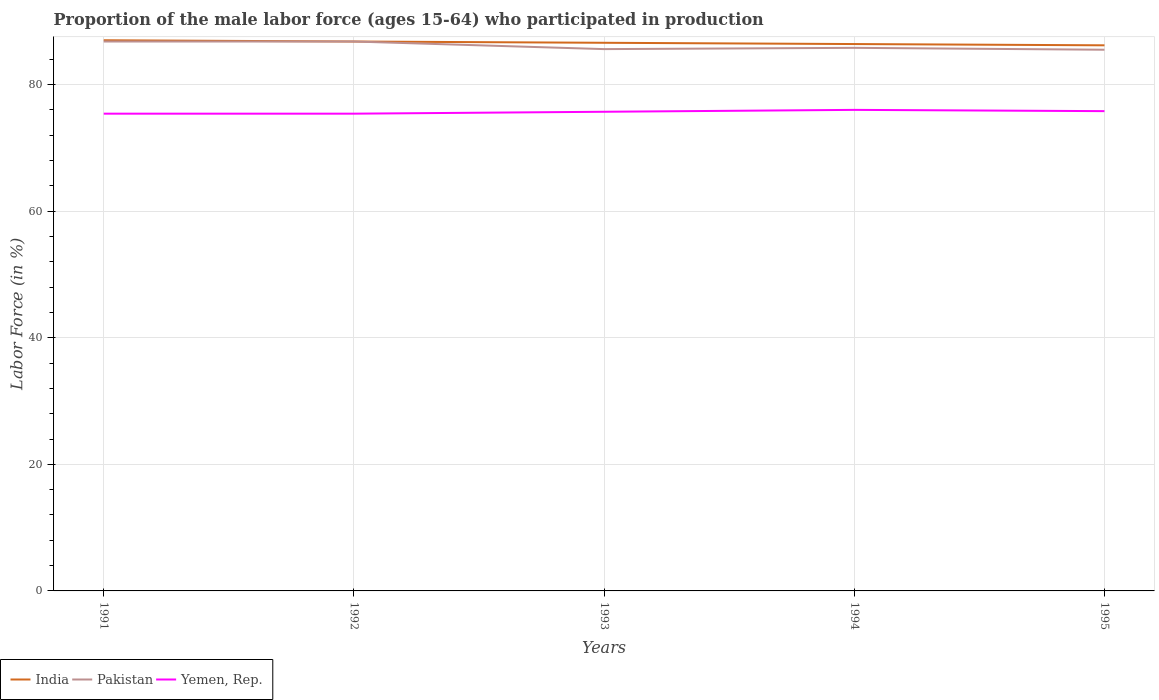Does the line corresponding to Pakistan intersect with the line corresponding to Yemen, Rep.?
Provide a succinct answer. No. Is the number of lines equal to the number of legend labels?
Your response must be concise. Yes. Across all years, what is the maximum proportion of the male labor force who participated in production in Yemen, Rep.?
Your response must be concise. 75.4. What is the total proportion of the male labor force who participated in production in India in the graph?
Your answer should be very brief. 0.4. What is the difference between the highest and the second highest proportion of the male labor force who participated in production in Pakistan?
Give a very brief answer. 1.3. Does the graph contain grids?
Make the answer very short. Yes. Where does the legend appear in the graph?
Your answer should be compact. Bottom left. How many legend labels are there?
Offer a terse response. 3. How are the legend labels stacked?
Provide a short and direct response. Horizontal. What is the title of the graph?
Give a very brief answer. Proportion of the male labor force (ages 15-64) who participated in production. What is the label or title of the X-axis?
Your answer should be very brief. Years. What is the Labor Force (in %) in Pakistan in 1991?
Give a very brief answer. 86.8. What is the Labor Force (in %) in Yemen, Rep. in 1991?
Make the answer very short. 75.4. What is the Labor Force (in %) in India in 1992?
Make the answer very short. 86.8. What is the Labor Force (in %) in Pakistan in 1992?
Provide a succinct answer. 86.8. What is the Labor Force (in %) of Yemen, Rep. in 1992?
Your response must be concise. 75.4. What is the Labor Force (in %) in India in 1993?
Your answer should be very brief. 86.6. What is the Labor Force (in %) in Pakistan in 1993?
Ensure brevity in your answer.  85.6. What is the Labor Force (in %) of Yemen, Rep. in 1993?
Offer a very short reply. 75.7. What is the Labor Force (in %) of India in 1994?
Make the answer very short. 86.4. What is the Labor Force (in %) of Pakistan in 1994?
Provide a short and direct response. 85.8. What is the Labor Force (in %) of Yemen, Rep. in 1994?
Ensure brevity in your answer.  76. What is the Labor Force (in %) of India in 1995?
Your answer should be very brief. 86.2. What is the Labor Force (in %) of Pakistan in 1995?
Ensure brevity in your answer.  85.5. What is the Labor Force (in %) in Yemen, Rep. in 1995?
Offer a very short reply. 75.8. Across all years, what is the maximum Labor Force (in %) of Pakistan?
Ensure brevity in your answer.  86.8. Across all years, what is the maximum Labor Force (in %) of Yemen, Rep.?
Ensure brevity in your answer.  76. Across all years, what is the minimum Labor Force (in %) of India?
Ensure brevity in your answer.  86.2. Across all years, what is the minimum Labor Force (in %) of Pakistan?
Keep it short and to the point. 85.5. Across all years, what is the minimum Labor Force (in %) in Yemen, Rep.?
Your answer should be very brief. 75.4. What is the total Labor Force (in %) of India in the graph?
Provide a succinct answer. 433. What is the total Labor Force (in %) of Pakistan in the graph?
Offer a terse response. 430.5. What is the total Labor Force (in %) in Yemen, Rep. in the graph?
Provide a succinct answer. 378.3. What is the difference between the Labor Force (in %) in Pakistan in 1991 and that in 1992?
Provide a short and direct response. 0. What is the difference between the Labor Force (in %) in Pakistan in 1991 and that in 1993?
Your response must be concise. 1.2. What is the difference between the Labor Force (in %) in Yemen, Rep. in 1991 and that in 1993?
Offer a very short reply. -0.3. What is the difference between the Labor Force (in %) of Pakistan in 1991 and that in 1994?
Your answer should be very brief. 1. What is the difference between the Labor Force (in %) in Yemen, Rep. in 1991 and that in 1994?
Your response must be concise. -0.6. What is the difference between the Labor Force (in %) in India in 1991 and that in 1995?
Offer a very short reply. 0.8. What is the difference between the Labor Force (in %) in Pakistan in 1991 and that in 1995?
Offer a terse response. 1.3. What is the difference between the Labor Force (in %) of Yemen, Rep. in 1991 and that in 1995?
Offer a terse response. -0.4. What is the difference between the Labor Force (in %) in India in 1992 and that in 1993?
Provide a succinct answer. 0.2. What is the difference between the Labor Force (in %) in India in 1992 and that in 1994?
Your response must be concise. 0.4. What is the difference between the Labor Force (in %) in Pakistan in 1992 and that in 1994?
Ensure brevity in your answer.  1. What is the difference between the Labor Force (in %) in Yemen, Rep. in 1992 and that in 1994?
Ensure brevity in your answer.  -0.6. What is the difference between the Labor Force (in %) in Yemen, Rep. in 1992 and that in 1995?
Provide a short and direct response. -0.4. What is the difference between the Labor Force (in %) of Pakistan in 1993 and that in 1994?
Provide a short and direct response. -0.2. What is the difference between the Labor Force (in %) in Yemen, Rep. in 1993 and that in 1994?
Provide a succinct answer. -0.3. What is the difference between the Labor Force (in %) of Pakistan in 1993 and that in 1995?
Your answer should be compact. 0.1. What is the difference between the Labor Force (in %) of India in 1994 and that in 1995?
Give a very brief answer. 0.2. What is the difference between the Labor Force (in %) in Pakistan in 1994 and that in 1995?
Offer a very short reply. 0.3. What is the difference between the Labor Force (in %) in Yemen, Rep. in 1994 and that in 1995?
Keep it short and to the point. 0.2. What is the difference between the Labor Force (in %) in India in 1991 and the Labor Force (in %) in Yemen, Rep. in 1992?
Offer a very short reply. 11.6. What is the difference between the Labor Force (in %) in India in 1991 and the Labor Force (in %) in Yemen, Rep. in 1993?
Offer a terse response. 11.3. What is the difference between the Labor Force (in %) of India in 1992 and the Labor Force (in %) of Yemen, Rep. in 1993?
Provide a short and direct response. 11.1. What is the difference between the Labor Force (in %) in India in 1992 and the Labor Force (in %) in Yemen, Rep. in 1994?
Keep it short and to the point. 10.8. What is the difference between the Labor Force (in %) of India in 1992 and the Labor Force (in %) of Pakistan in 1995?
Provide a short and direct response. 1.3. What is the difference between the Labor Force (in %) of Pakistan in 1992 and the Labor Force (in %) of Yemen, Rep. in 1995?
Provide a succinct answer. 11. What is the difference between the Labor Force (in %) in India in 1993 and the Labor Force (in %) in Pakistan in 1994?
Offer a terse response. 0.8. What is the difference between the Labor Force (in %) of India in 1993 and the Labor Force (in %) of Yemen, Rep. in 1994?
Provide a succinct answer. 10.6. What is the difference between the Labor Force (in %) of Pakistan in 1993 and the Labor Force (in %) of Yemen, Rep. in 1994?
Make the answer very short. 9.6. What is the difference between the Labor Force (in %) in India in 1994 and the Labor Force (in %) in Pakistan in 1995?
Provide a succinct answer. 0.9. What is the difference between the Labor Force (in %) of India in 1994 and the Labor Force (in %) of Yemen, Rep. in 1995?
Provide a short and direct response. 10.6. What is the average Labor Force (in %) in India per year?
Your response must be concise. 86.6. What is the average Labor Force (in %) in Pakistan per year?
Offer a very short reply. 86.1. What is the average Labor Force (in %) of Yemen, Rep. per year?
Offer a very short reply. 75.66. In the year 1991, what is the difference between the Labor Force (in %) in India and Labor Force (in %) in Yemen, Rep.?
Provide a short and direct response. 11.6. In the year 1991, what is the difference between the Labor Force (in %) of Pakistan and Labor Force (in %) of Yemen, Rep.?
Your answer should be very brief. 11.4. In the year 1992, what is the difference between the Labor Force (in %) in India and Labor Force (in %) in Pakistan?
Keep it short and to the point. 0. In the year 1992, what is the difference between the Labor Force (in %) of India and Labor Force (in %) of Yemen, Rep.?
Provide a short and direct response. 11.4. In the year 1992, what is the difference between the Labor Force (in %) of Pakistan and Labor Force (in %) of Yemen, Rep.?
Ensure brevity in your answer.  11.4. In the year 1993, what is the difference between the Labor Force (in %) of India and Labor Force (in %) of Pakistan?
Offer a terse response. 1. In the year 1993, what is the difference between the Labor Force (in %) of India and Labor Force (in %) of Yemen, Rep.?
Your response must be concise. 10.9. In the year 1993, what is the difference between the Labor Force (in %) of Pakistan and Labor Force (in %) of Yemen, Rep.?
Keep it short and to the point. 9.9. In the year 1994, what is the difference between the Labor Force (in %) in India and Labor Force (in %) in Yemen, Rep.?
Offer a very short reply. 10.4. In the year 1994, what is the difference between the Labor Force (in %) of Pakistan and Labor Force (in %) of Yemen, Rep.?
Give a very brief answer. 9.8. In the year 1995, what is the difference between the Labor Force (in %) of India and Labor Force (in %) of Pakistan?
Provide a short and direct response. 0.7. What is the ratio of the Labor Force (in %) in Pakistan in 1991 to that in 1992?
Your answer should be compact. 1. What is the ratio of the Labor Force (in %) of India in 1991 to that in 1993?
Give a very brief answer. 1. What is the ratio of the Labor Force (in %) in Pakistan in 1991 to that in 1993?
Make the answer very short. 1.01. What is the ratio of the Labor Force (in %) in Yemen, Rep. in 1991 to that in 1993?
Give a very brief answer. 1. What is the ratio of the Labor Force (in %) in India in 1991 to that in 1994?
Your answer should be compact. 1.01. What is the ratio of the Labor Force (in %) in Pakistan in 1991 to that in 1994?
Give a very brief answer. 1.01. What is the ratio of the Labor Force (in %) of India in 1991 to that in 1995?
Your answer should be compact. 1.01. What is the ratio of the Labor Force (in %) of Pakistan in 1991 to that in 1995?
Your answer should be very brief. 1.02. What is the ratio of the Labor Force (in %) in Yemen, Rep. in 1991 to that in 1995?
Ensure brevity in your answer.  0.99. What is the ratio of the Labor Force (in %) of Pakistan in 1992 to that in 1993?
Give a very brief answer. 1.01. What is the ratio of the Labor Force (in %) in India in 1992 to that in 1994?
Your answer should be very brief. 1. What is the ratio of the Labor Force (in %) in Pakistan in 1992 to that in 1994?
Ensure brevity in your answer.  1.01. What is the ratio of the Labor Force (in %) of Yemen, Rep. in 1992 to that in 1994?
Offer a very short reply. 0.99. What is the ratio of the Labor Force (in %) in India in 1992 to that in 1995?
Offer a very short reply. 1.01. What is the ratio of the Labor Force (in %) of Pakistan in 1992 to that in 1995?
Provide a succinct answer. 1.02. What is the ratio of the Labor Force (in %) of Yemen, Rep. in 1993 to that in 1994?
Keep it short and to the point. 1. What is the ratio of the Labor Force (in %) of Pakistan in 1994 to that in 1995?
Provide a short and direct response. 1. What is the ratio of the Labor Force (in %) in Yemen, Rep. in 1994 to that in 1995?
Offer a very short reply. 1. What is the difference between the highest and the second highest Labor Force (in %) in Pakistan?
Keep it short and to the point. 0. What is the difference between the highest and the second highest Labor Force (in %) in Yemen, Rep.?
Your answer should be compact. 0.2. What is the difference between the highest and the lowest Labor Force (in %) of India?
Give a very brief answer. 0.8. What is the difference between the highest and the lowest Labor Force (in %) in Pakistan?
Keep it short and to the point. 1.3. What is the difference between the highest and the lowest Labor Force (in %) in Yemen, Rep.?
Ensure brevity in your answer.  0.6. 